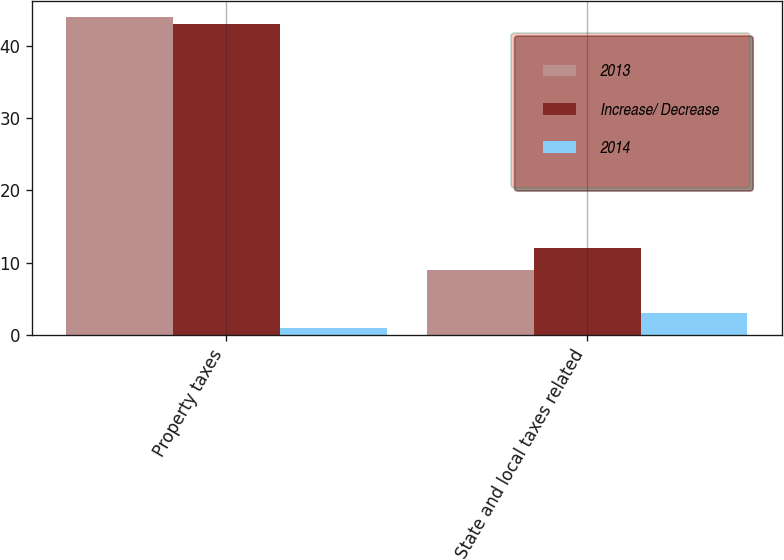Convert chart to OTSL. <chart><loc_0><loc_0><loc_500><loc_500><stacked_bar_chart><ecel><fcel>Property taxes<fcel>State and local taxes related<nl><fcel>2013<fcel>44<fcel>9<nl><fcel>Increase/ Decrease<fcel>43<fcel>12<nl><fcel>2014<fcel>1<fcel>3<nl></chart> 